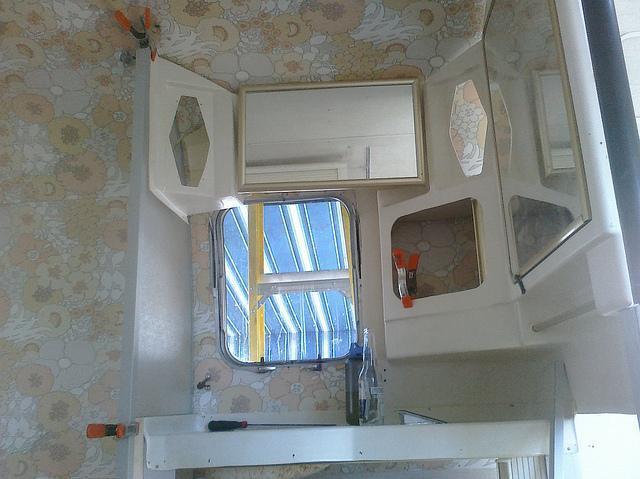How many people are in dresses?
Give a very brief answer. 0. 